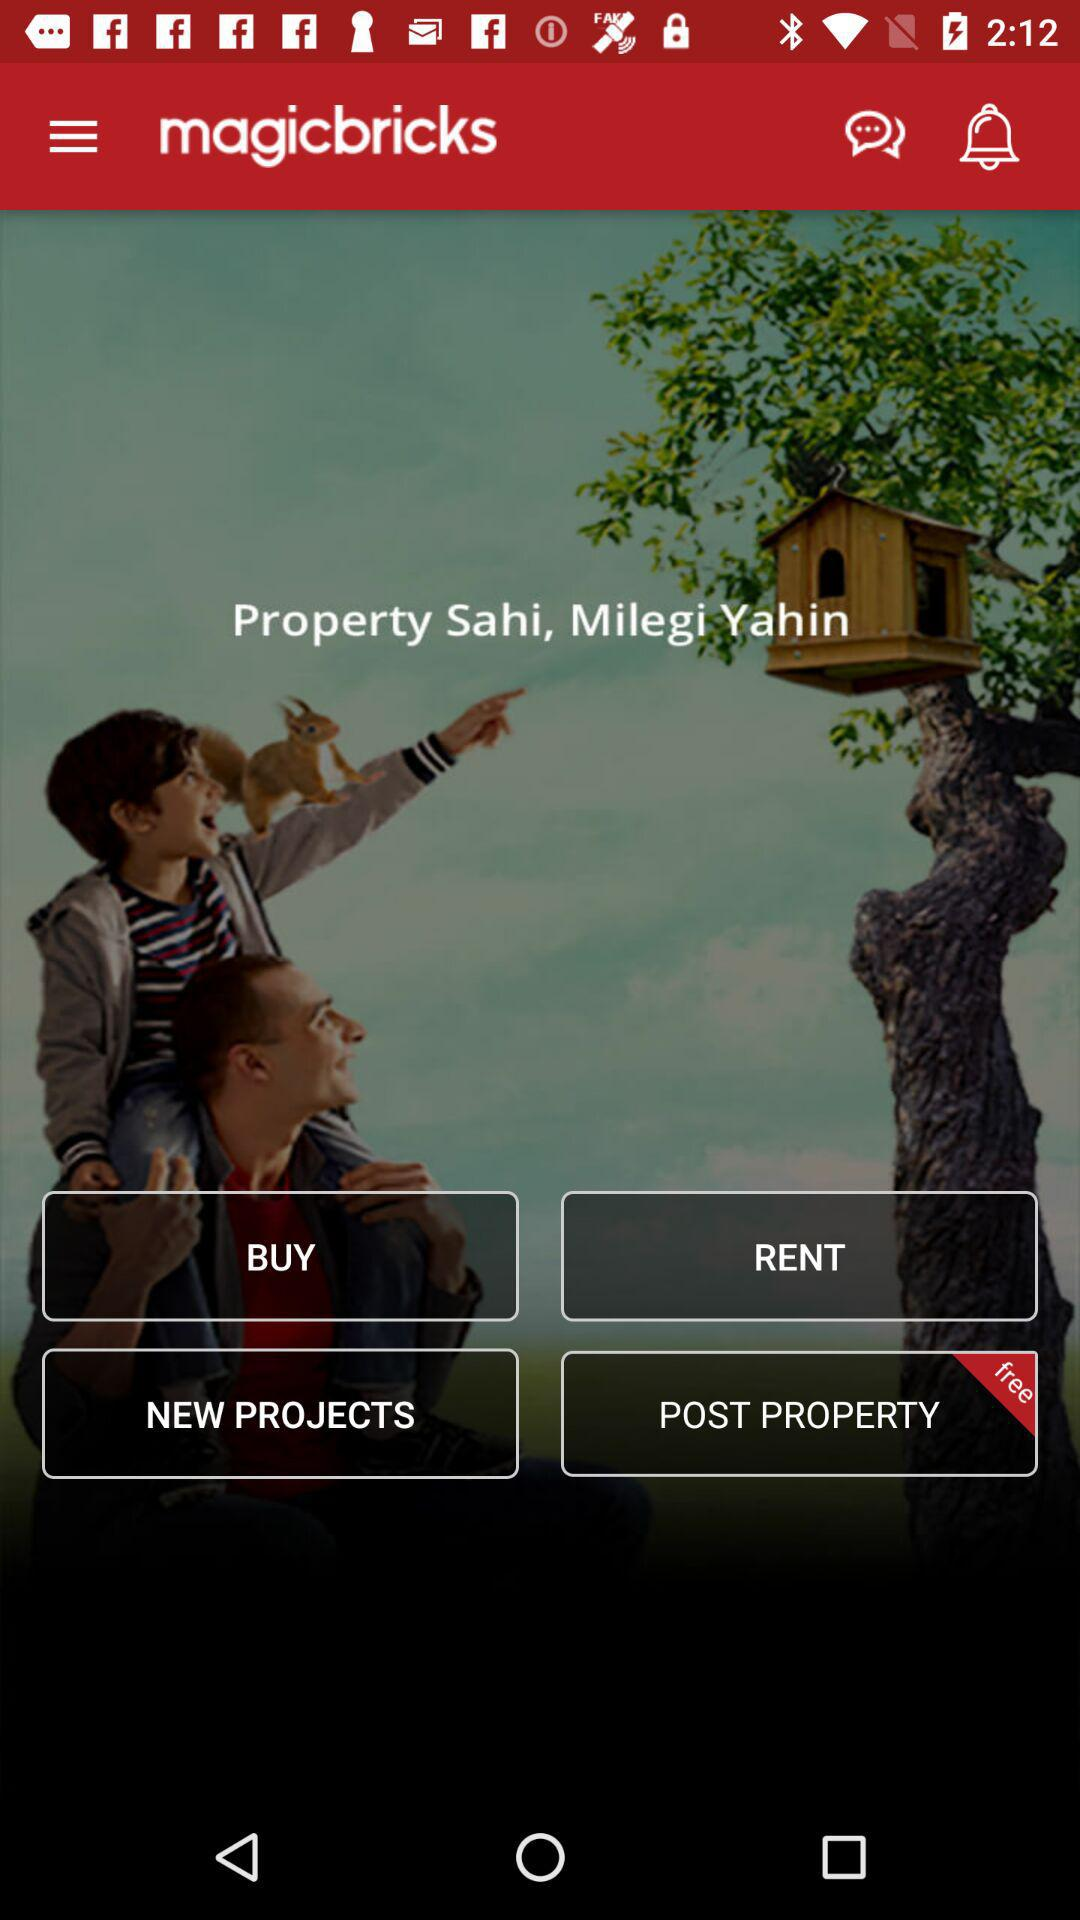Which option is available for free? The option available for free is "POST PROPERTY". 